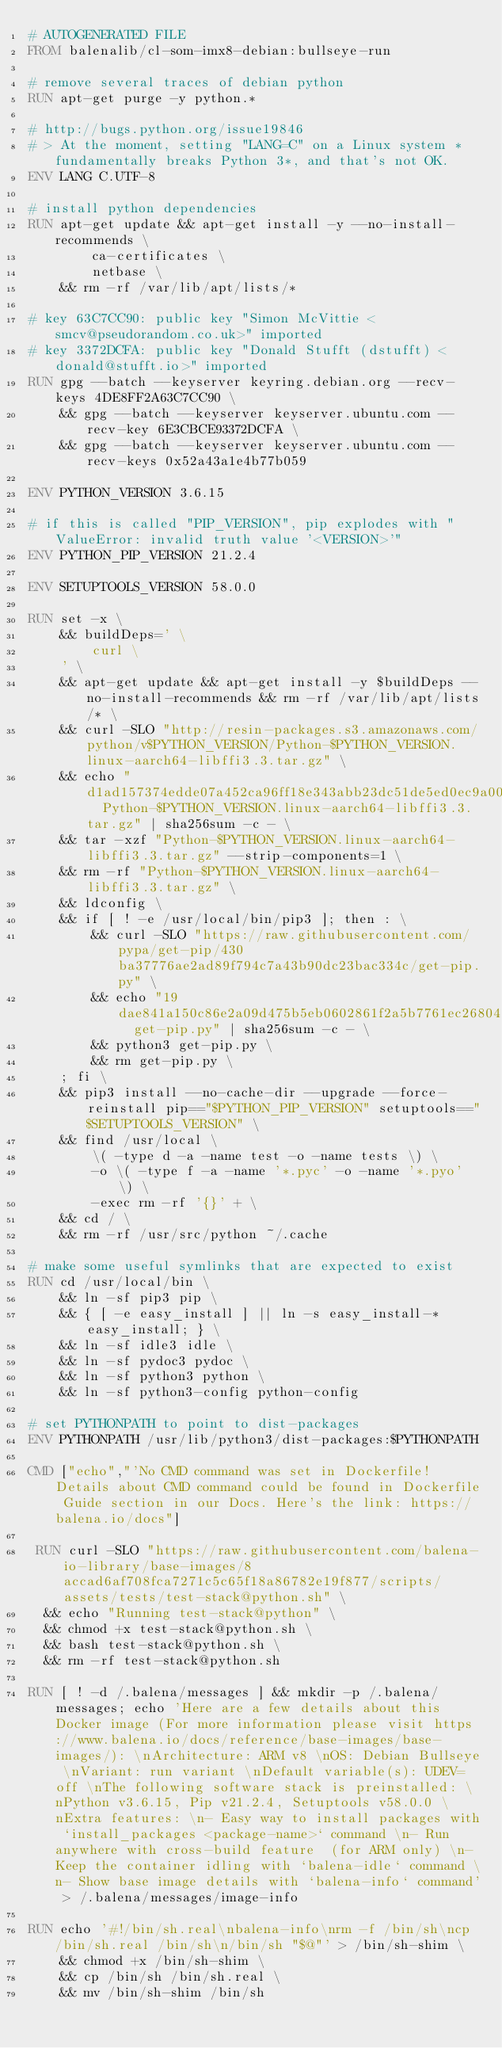<code> <loc_0><loc_0><loc_500><loc_500><_Dockerfile_># AUTOGENERATED FILE
FROM balenalib/cl-som-imx8-debian:bullseye-run

# remove several traces of debian python
RUN apt-get purge -y python.*

# http://bugs.python.org/issue19846
# > At the moment, setting "LANG=C" on a Linux system *fundamentally breaks Python 3*, and that's not OK.
ENV LANG C.UTF-8

# install python dependencies
RUN apt-get update && apt-get install -y --no-install-recommends \
		ca-certificates \
		netbase \
	&& rm -rf /var/lib/apt/lists/*

# key 63C7CC90: public key "Simon McVittie <smcv@pseudorandom.co.uk>" imported
# key 3372DCFA: public key "Donald Stufft (dstufft) <donald@stufft.io>" imported
RUN gpg --batch --keyserver keyring.debian.org --recv-keys 4DE8FF2A63C7CC90 \
	&& gpg --batch --keyserver keyserver.ubuntu.com --recv-key 6E3CBCE93372DCFA \
	&& gpg --batch --keyserver keyserver.ubuntu.com --recv-keys 0x52a43a1e4b77b059

ENV PYTHON_VERSION 3.6.15

# if this is called "PIP_VERSION", pip explodes with "ValueError: invalid truth value '<VERSION>'"
ENV PYTHON_PIP_VERSION 21.2.4

ENV SETUPTOOLS_VERSION 58.0.0

RUN set -x \
	&& buildDeps=' \
		curl \
	' \
	&& apt-get update && apt-get install -y $buildDeps --no-install-recommends && rm -rf /var/lib/apt/lists/* \
	&& curl -SLO "http://resin-packages.s3.amazonaws.com/python/v$PYTHON_VERSION/Python-$PYTHON_VERSION.linux-aarch64-libffi3.3.tar.gz" \
	&& echo "d1ad157374edde07a452ca96ff18e343abb23dc51de5ed0ec9a0091ae6005a70  Python-$PYTHON_VERSION.linux-aarch64-libffi3.3.tar.gz" | sha256sum -c - \
	&& tar -xzf "Python-$PYTHON_VERSION.linux-aarch64-libffi3.3.tar.gz" --strip-components=1 \
	&& rm -rf "Python-$PYTHON_VERSION.linux-aarch64-libffi3.3.tar.gz" \
	&& ldconfig \
	&& if [ ! -e /usr/local/bin/pip3 ]; then : \
		&& curl -SLO "https://raw.githubusercontent.com/pypa/get-pip/430ba37776ae2ad89f794c7a43b90dc23bac334c/get-pip.py" \
		&& echo "19dae841a150c86e2a09d475b5eb0602861f2a5b7761ec268049a662dbd2bd0c  get-pip.py" | sha256sum -c - \
		&& python3 get-pip.py \
		&& rm get-pip.py \
	; fi \
	&& pip3 install --no-cache-dir --upgrade --force-reinstall pip=="$PYTHON_PIP_VERSION" setuptools=="$SETUPTOOLS_VERSION" \
	&& find /usr/local \
		\( -type d -a -name test -o -name tests \) \
		-o \( -type f -a -name '*.pyc' -o -name '*.pyo' \) \
		-exec rm -rf '{}' + \
	&& cd / \
	&& rm -rf /usr/src/python ~/.cache

# make some useful symlinks that are expected to exist
RUN cd /usr/local/bin \
	&& ln -sf pip3 pip \
	&& { [ -e easy_install ] || ln -s easy_install-* easy_install; } \
	&& ln -sf idle3 idle \
	&& ln -sf pydoc3 pydoc \
	&& ln -sf python3 python \
	&& ln -sf python3-config python-config

# set PYTHONPATH to point to dist-packages
ENV PYTHONPATH /usr/lib/python3/dist-packages:$PYTHONPATH

CMD ["echo","'No CMD command was set in Dockerfile! Details about CMD command could be found in Dockerfile Guide section in our Docs. Here's the link: https://balena.io/docs"]

 RUN curl -SLO "https://raw.githubusercontent.com/balena-io-library/base-images/8accad6af708fca7271c5c65f18a86782e19f877/scripts/assets/tests/test-stack@python.sh" \
  && echo "Running test-stack@python" \
  && chmod +x test-stack@python.sh \
  && bash test-stack@python.sh \
  && rm -rf test-stack@python.sh 

RUN [ ! -d /.balena/messages ] && mkdir -p /.balena/messages; echo 'Here are a few details about this Docker image (For more information please visit https://www.balena.io/docs/reference/base-images/base-images/): \nArchitecture: ARM v8 \nOS: Debian Bullseye \nVariant: run variant \nDefault variable(s): UDEV=off \nThe following software stack is preinstalled: \nPython v3.6.15, Pip v21.2.4, Setuptools v58.0.0 \nExtra features: \n- Easy way to install packages with `install_packages <package-name>` command \n- Run anywhere with cross-build feature  (for ARM only) \n- Keep the container idling with `balena-idle` command \n- Show base image details with `balena-info` command' > /.balena/messages/image-info

RUN echo '#!/bin/sh.real\nbalena-info\nrm -f /bin/sh\ncp /bin/sh.real /bin/sh\n/bin/sh "$@"' > /bin/sh-shim \
	&& chmod +x /bin/sh-shim \
	&& cp /bin/sh /bin/sh.real \
	&& mv /bin/sh-shim /bin/sh</code> 